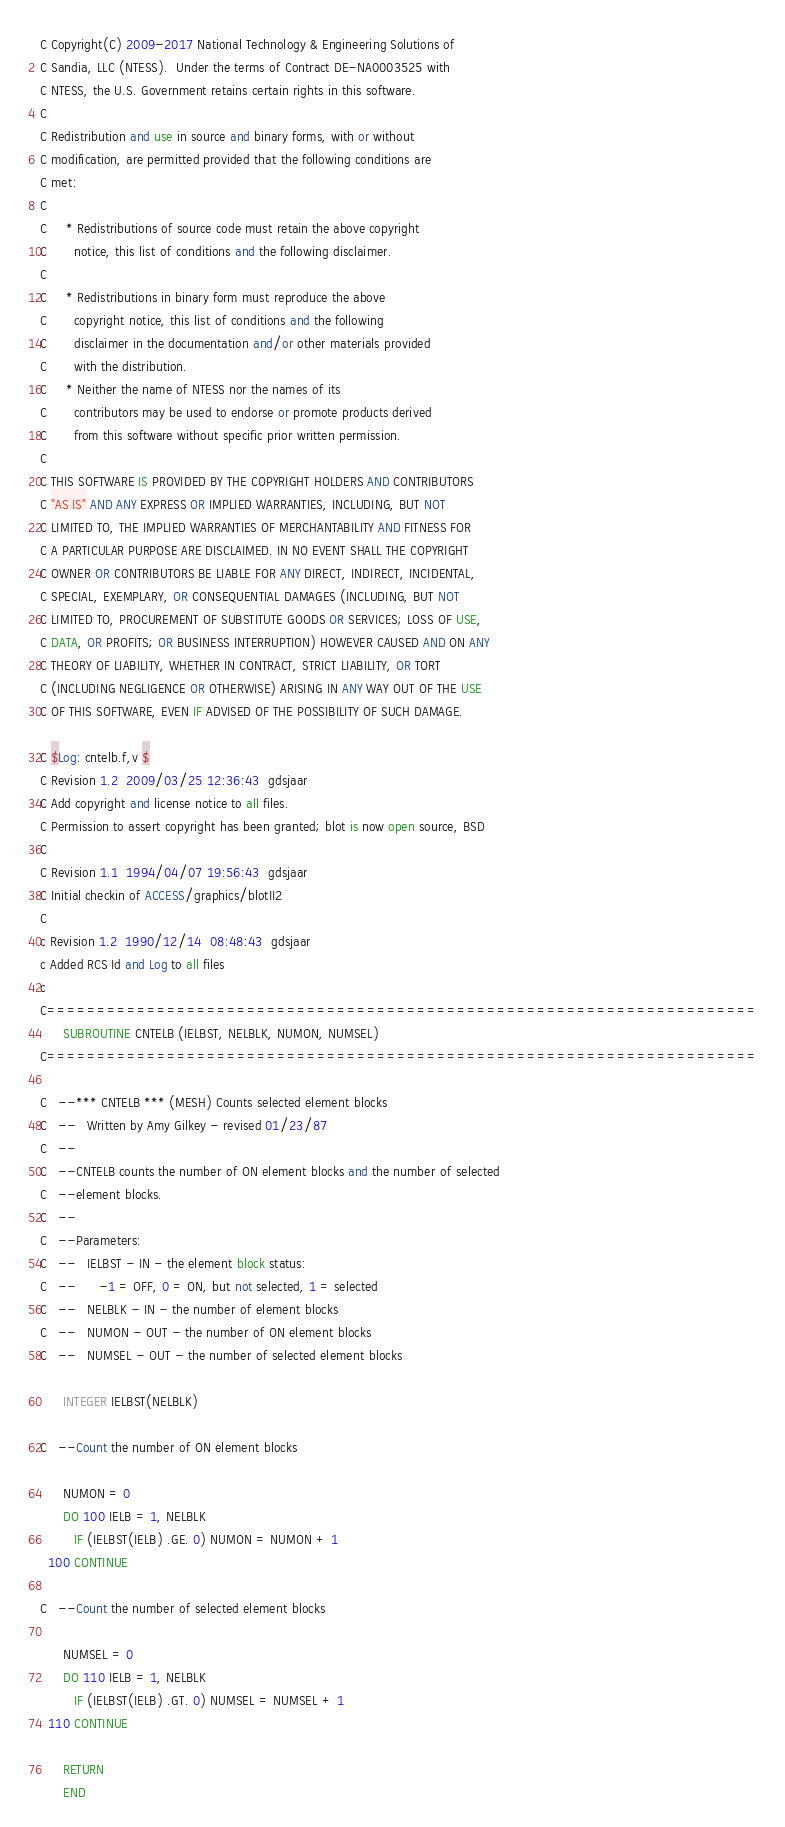<code> <loc_0><loc_0><loc_500><loc_500><_FORTRAN_>C Copyright(C) 2009-2017 National Technology & Engineering Solutions of
C Sandia, LLC (NTESS).  Under the terms of Contract DE-NA0003525 with
C NTESS, the U.S. Government retains certain rights in this software.
C 
C Redistribution and use in source and binary forms, with or without
C modification, are permitted provided that the following conditions are
C met:
C 
C     * Redistributions of source code must retain the above copyright
C       notice, this list of conditions and the following disclaimer.
C 
C     * Redistributions in binary form must reproduce the above
C       copyright notice, this list of conditions and the following
C       disclaimer in the documentation and/or other materials provided
C       with the distribution.
C     * Neither the name of NTESS nor the names of its
C       contributors may be used to endorse or promote products derived
C       from this software without specific prior written permission.
C 
C THIS SOFTWARE IS PROVIDED BY THE COPYRIGHT HOLDERS AND CONTRIBUTORS
C "AS IS" AND ANY EXPRESS OR IMPLIED WARRANTIES, INCLUDING, BUT NOT
C LIMITED TO, THE IMPLIED WARRANTIES OF MERCHANTABILITY AND FITNESS FOR
C A PARTICULAR PURPOSE ARE DISCLAIMED. IN NO EVENT SHALL THE COPYRIGHT
C OWNER OR CONTRIBUTORS BE LIABLE FOR ANY DIRECT, INDIRECT, INCIDENTAL,
C SPECIAL, EXEMPLARY, OR CONSEQUENTIAL DAMAGES (INCLUDING, BUT NOT
C LIMITED TO, PROCUREMENT OF SUBSTITUTE GOODS OR SERVICES; LOSS OF USE,
C DATA, OR PROFITS; OR BUSINESS INTERRUPTION) HOWEVER CAUSED AND ON ANY
C THEORY OF LIABILITY, WHETHER IN CONTRACT, STRICT LIABILITY, OR TORT
C (INCLUDING NEGLIGENCE OR OTHERWISE) ARISING IN ANY WAY OUT OF THE USE
C OF THIS SOFTWARE, EVEN IF ADVISED OF THE POSSIBILITY OF SUCH DAMAGE.

C $Log: cntelb.f,v $
C Revision 1.2  2009/03/25 12:36:43  gdsjaar
C Add copyright and license notice to all files.
C Permission to assert copyright has been granted; blot is now open source, BSD
C
C Revision 1.1  1994/04/07 19:56:43  gdsjaar
C Initial checkin of ACCESS/graphics/blotII2
C
c Revision 1.2  1990/12/14  08:48:43  gdsjaar
c Added RCS Id and Log to all files
c
C=======================================================================
      SUBROUTINE CNTELB (IELBST, NELBLK, NUMON, NUMSEL)
C=======================================================================

C   --*** CNTELB *** (MESH) Counts selected element blocks
C   --   Written by Amy Gilkey - revised 01/23/87
C   --
C   --CNTELB counts the number of ON element blocks and the number of selected
C   --element blocks.
C   --
C   --Parameters:
C   --   IELBST - IN - the element block status:
C   --      -1 = OFF, 0 = ON, but not selected, 1 = selected
C   --   NELBLK - IN - the number of element blocks
C   --   NUMON - OUT - the number of ON element blocks
C   --   NUMSEL - OUT - the number of selected element blocks

      INTEGER IELBST(NELBLK)

C   --Count the number of ON element blocks

      NUMON = 0
      DO 100 IELB = 1, NELBLK
         IF (IELBST(IELB) .GE. 0) NUMON = NUMON + 1
  100 CONTINUE

C   --Count the number of selected element blocks

      NUMSEL = 0
      DO 110 IELB = 1, NELBLK
         IF (IELBST(IELB) .GT. 0) NUMSEL = NUMSEL + 1
  110 CONTINUE

      RETURN
      END
</code> 